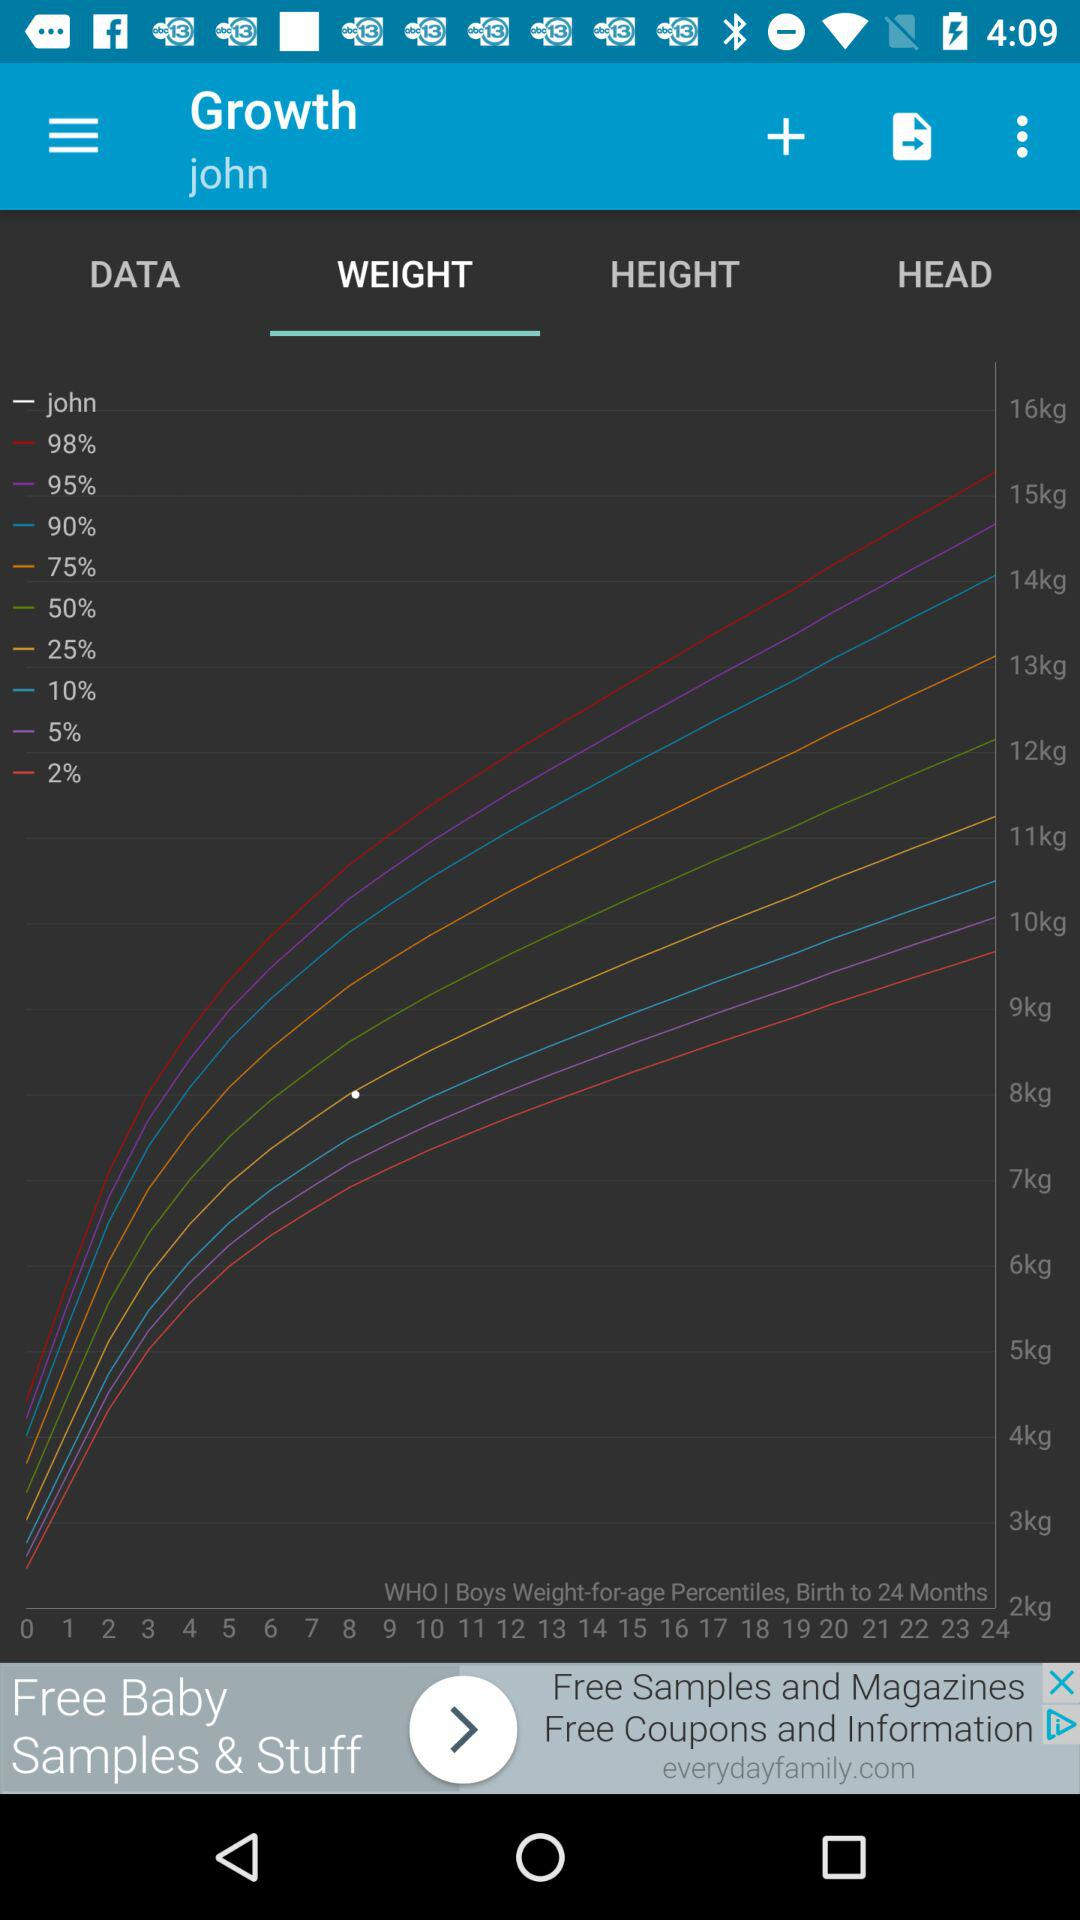What is the user name? The user name is John. 